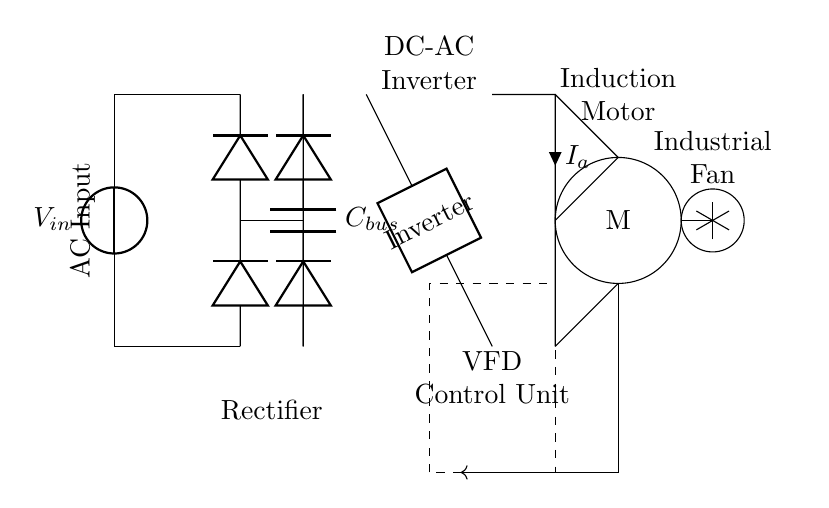What is the type of power source in this circuit? The circuit uses an AC voltage source, indicated by the vsource symbol labeled with V_in at the left of the diagram.
Answer: AC voltage source What component is responsible for converting AC to DC? The rectifier is responsible for this function; it is shown between the AC input and the DC bus, represented by two diodes connected in a bridge configuration.
Answer: Rectifier What is the purpose of the capacitor labeled C_bus? The capacitor C_bus stores the DC voltage, smoothing out fluctuations and providing stability in the DC bus after rectification.
Answer: Smooth DC voltage How many diodes are present in the rectifier section? There are four diodes illustrated in the rectifier section, forming a bridge rectifier configuration to convert AC to DC.
Answer: Four diodes What type of load is connected to the motor in this circuit? The load connected to the motor is an industrial fan, denoted by a circular shape with fan blades drawn around it in the diagram.
Answer: Industrial fan Which component modulates the frequency to control the motor speed? The VFD Control Unit modulates the frequency of the output provided to the motor, allowing for variable speed control in the facility.
Answer: VFD Control Unit What is the direction of feedback to the control unit? The feedback direction is indicated by the arrow originating from the motor and leading back to the VFD Control Unit, showing the control loop in action.
Answer: Feedback direction is indicated by an arrow 